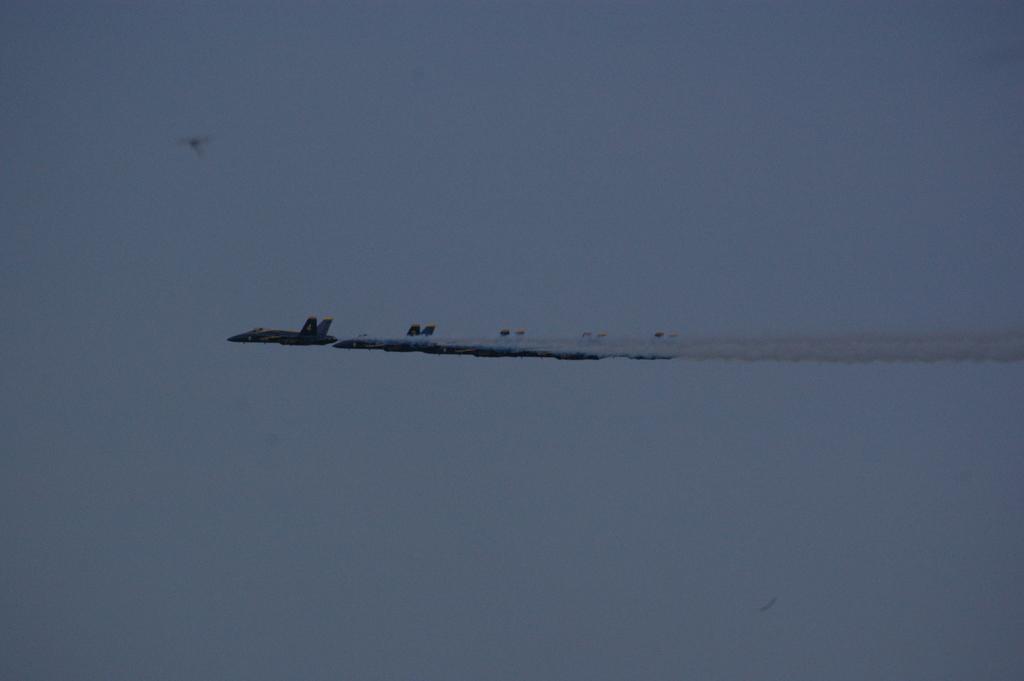Please provide a concise description of this image. In this picture I can see aircrafts flying, and in the background there is the sky. 